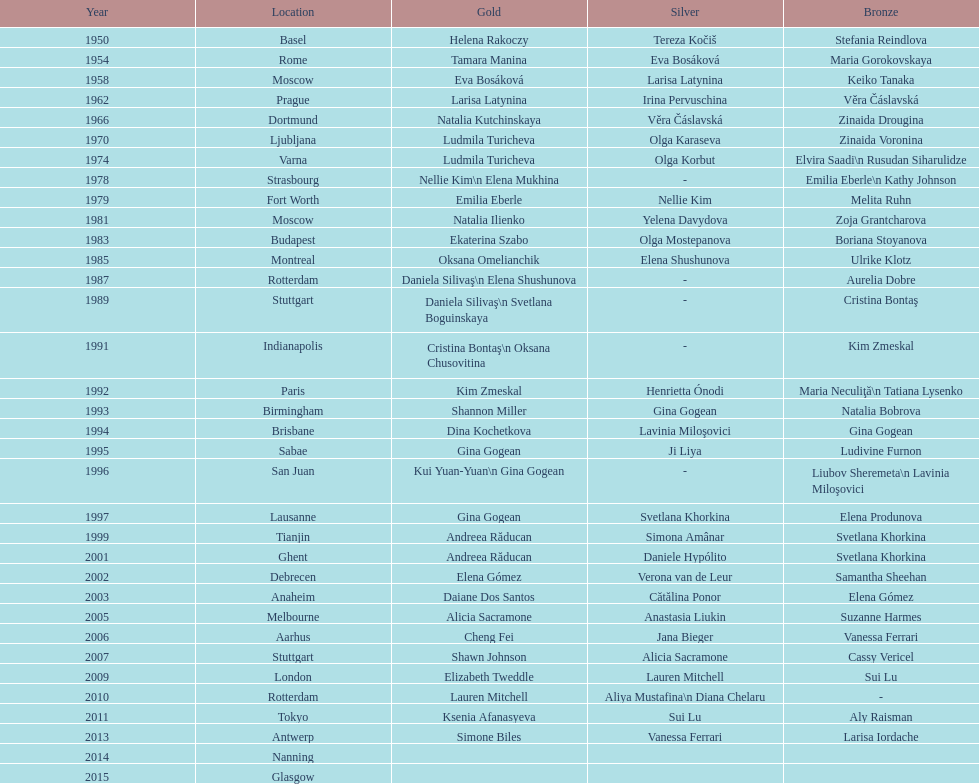Which two american opponents achieved consecutive floor exercise gold medals at the artistic gymnastics world championships in 1992 and 1993? Kim Zmeskal, Shannon Miller. 